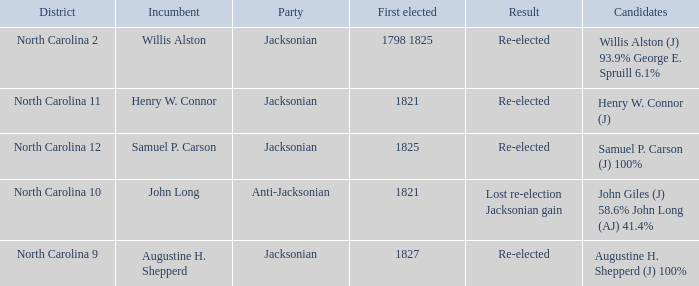Name the result for  augustine h. shepperd (j) 100% Re-elected. Parse the table in full. {'header': ['District', 'Incumbent', 'Party', 'First elected', 'Result', 'Candidates'], 'rows': [['North Carolina 2', 'Willis Alston', 'Jacksonian', '1798 1825', 'Re-elected', 'Willis Alston (J) 93.9% George E. Spruill 6.1%'], ['North Carolina 11', 'Henry W. Connor', 'Jacksonian', '1821', 'Re-elected', 'Henry W. Connor (J)'], ['North Carolina 12', 'Samuel P. Carson', 'Jacksonian', '1825', 'Re-elected', 'Samuel P. Carson (J) 100%'], ['North Carolina 10', 'John Long', 'Anti-Jacksonian', '1821', 'Lost re-election Jacksonian gain', 'John Giles (J) 58.6% John Long (AJ) 41.4%'], ['North Carolina 9', 'Augustine H. Shepperd', 'Jacksonian', '1827', 'Re-elected', 'Augustine H. Shepperd (J) 100%']]} 